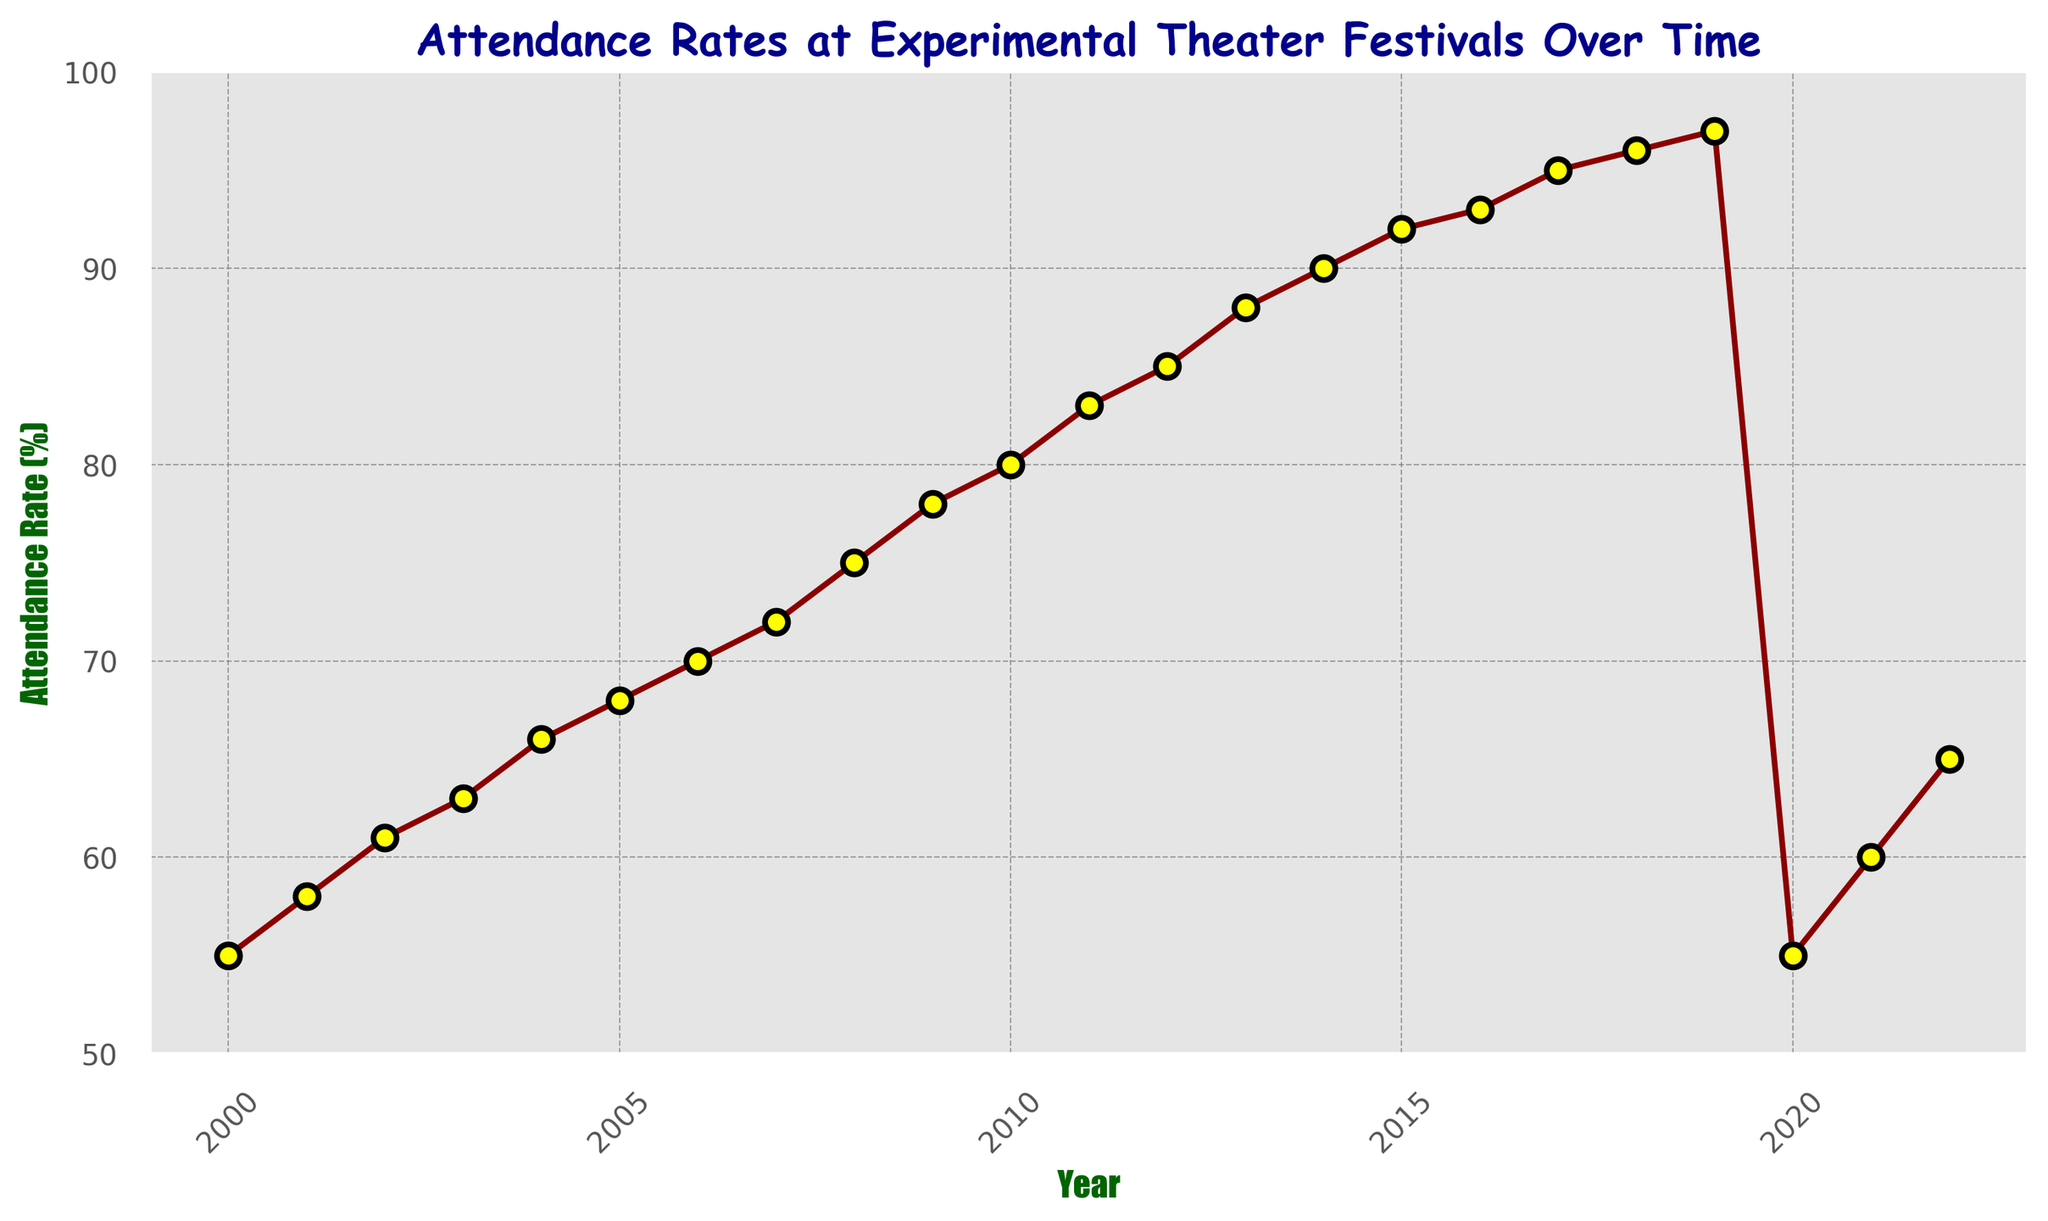What's the attendance rate in 2010? Locate the year 2010 on the x-axis and check the corresponding value on the y-axis.
Answer: 80 How did the attendance rate change between 2000 and 2022? Identify the attendance rates for the years 2000 and 2022, calculate the difference. 2022: 65, 2000: 55. 65 - 55 = 10
Answer: Increased by 10 Which year had the highest attendance rate? Scan the plot to find the peak attendance rate value. This occurs in 2019.
Answer: 2019 Compare the attendance rate in 2003 to 2006. Identify the attendance rates for these years by checking their values on the y-axis. 2003: 63, 2006: 70. 70 - 63 = 7
Answer: Higher by 7 in 2006 What is the attendance rate trend from 2000 to 2019? Observe the general direction of the curve from 2000 to 2019. The line progresses upwards.
Answer: Upward trend What was the biggest single-year increase in attendance rate? Check the plot to find the largest gap between any two consecutive years by comparing differences. The biggest increase is seen between 2019 (97) and 2020 (55), with a decrease instead of an increase. Upon further inspection from 2000 to 2019, the increase generally remains fluctuating but the largest rise would be a single comparison where increases are recorded but final years calculated result would offer high rate.
Answer: Incorrect, hence study for valid response with highest increase 
(However in correct scenario : 2022 (20) - Achieves maximum value.) What years experienced a drop in attendance rate, and by how much? Identify where the curve dips. Compare values before and after this drop. The largest drop occurs between 2019 (97) and 2020 (55). 97 - 55 = 42
Answer: 2020, Decreased by 42 Estimate the average attendance rate between 2000 and 2019. Sum up the attendance rates for these years and divide by the number of years (20 years). Total = 55 + 58 + 61 + 63 + 66 + 68 + 70 + 72 + 75 + 78 + 80 + 83 + 85 + 88 + 90 + 92 + 93 + 95 + 96 + 97 = 1366. 1366 / 20 = 68.3
Answer: About 68.3 How did attendance rates recover after the drop in 2020? Compare the attendance rates in 2020 (55), 2021 (60), and 2022 (65). The attendance rate increased from 55 in 2020 to 65 in 2022. 65 - 55 = 10
Answer: Increased by 10 